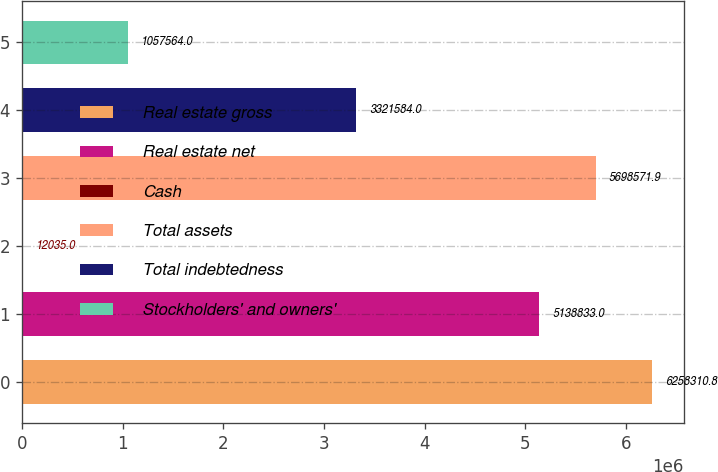Convert chart to OTSL. <chart><loc_0><loc_0><loc_500><loc_500><bar_chart><fcel>Real estate gross<fcel>Real estate net<fcel>Cash<fcel>Total assets<fcel>Total indebtedness<fcel>Stockholders' and owners'<nl><fcel>6.25831e+06<fcel>5.13883e+06<fcel>12035<fcel>5.69857e+06<fcel>3.32158e+06<fcel>1.05756e+06<nl></chart> 